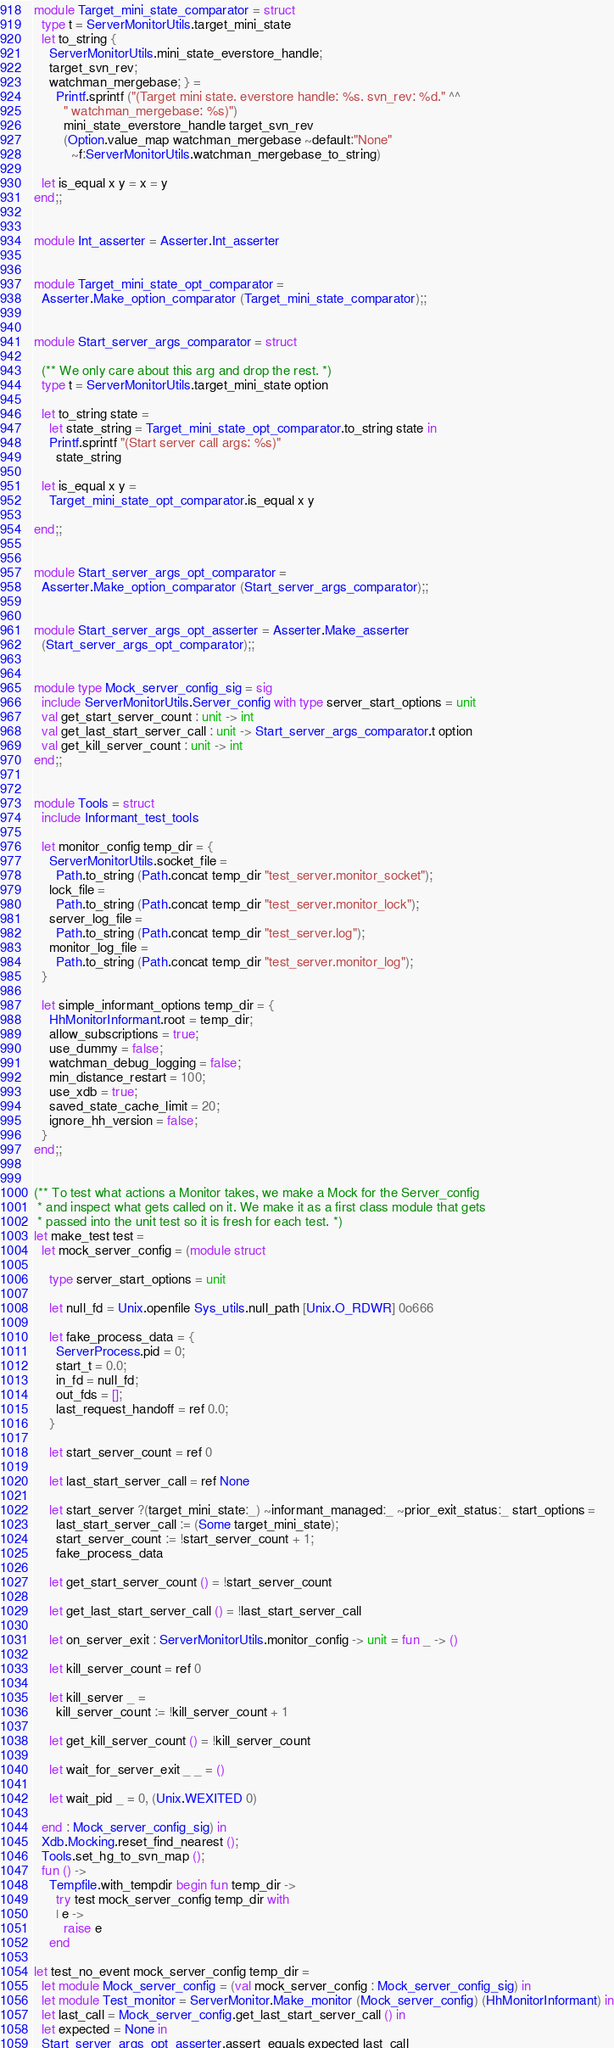Convert code to text. <code><loc_0><loc_0><loc_500><loc_500><_OCaml_>module Target_mini_state_comparator = struct
  type t = ServerMonitorUtils.target_mini_state
  let to_string {
    ServerMonitorUtils.mini_state_everstore_handle;
    target_svn_rev;
    watchman_mergebase; } =
      Printf.sprintf ("(Target mini state. everstore handle: %s. svn_rev: %d." ^^
        " watchman_mergebase: %s)")
        mini_state_everstore_handle target_svn_rev
        (Option.value_map watchman_mergebase ~default:"None"
          ~f:ServerMonitorUtils.watchman_mergebase_to_string)

  let is_equal x y = x = y
end;;


module Int_asserter = Asserter.Int_asserter


module Target_mini_state_opt_comparator =
  Asserter.Make_option_comparator (Target_mini_state_comparator);;


module Start_server_args_comparator = struct

  (** We only care about this arg and drop the rest. *)
  type t = ServerMonitorUtils.target_mini_state option

  let to_string state =
    let state_string = Target_mini_state_opt_comparator.to_string state in
    Printf.sprintf "(Start server call args: %s)"
      state_string

  let is_equal x y =
    Target_mini_state_opt_comparator.is_equal x y

end;;


module Start_server_args_opt_comparator =
  Asserter.Make_option_comparator (Start_server_args_comparator);;


module Start_server_args_opt_asserter = Asserter.Make_asserter
  (Start_server_args_opt_comparator);;


module type Mock_server_config_sig = sig
  include ServerMonitorUtils.Server_config with type server_start_options = unit
  val get_start_server_count : unit -> int
  val get_last_start_server_call : unit -> Start_server_args_comparator.t option
  val get_kill_server_count : unit -> int
end;;


module Tools = struct
  include Informant_test_tools

  let monitor_config temp_dir = {
    ServerMonitorUtils.socket_file =
      Path.to_string (Path.concat temp_dir "test_server.monitor_socket");
    lock_file =
      Path.to_string (Path.concat temp_dir "test_server.monitor_lock");
    server_log_file =
      Path.to_string (Path.concat temp_dir "test_server.log");
    monitor_log_file =
      Path.to_string (Path.concat temp_dir "test_server.monitor_log");
  }

  let simple_informant_options temp_dir = {
    HhMonitorInformant.root = temp_dir;
    allow_subscriptions = true;
    use_dummy = false;
    watchman_debug_logging = false;
    min_distance_restart = 100;
    use_xdb = true;
    saved_state_cache_limit = 20;
    ignore_hh_version = false;
  }
end;;


(** To test what actions a Monitor takes, we make a Mock for the Server_config
 * and inspect what gets called on it. We make it as a first class module that gets
 * passed into the unit test so it is fresh for each test. *)
let make_test test =
  let mock_server_config = (module struct

    type server_start_options = unit

    let null_fd = Unix.openfile Sys_utils.null_path [Unix.O_RDWR] 0o666

    let fake_process_data = {
      ServerProcess.pid = 0;
      start_t = 0.0;
      in_fd = null_fd;
      out_fds = [];
      last_request_handoff = ref 0.0;
    }

    let start_server_count = ref 0

    let last_start_server_call = ref None

    let start_server ?(target_mini_state:_) ~informant_managed:_ ~prior_exit_status:_ start_options =
      last_start_server_call := (Some target_mini_state);
      start_server_count := !start_server_count + 1;
      fake_process_data

    let get_start_server_count () = !start_server_count

    let get_last_start_server_call () = !last_start_server_call

    let on_server_exit : ServerMonitorUtils.monitor_config -> unit = fun _ -> ()

    let kill_server_count = ref 0

    let kill_server _ =
      kill_server_count := !kill_server_count + 1

    let get_kill_server_count () = !kill_server_count

    let wait_for_server_exit _ _ = ()

    let wait_pid _ = 0, (Unix.WEXITED 0)

  end : Mock_server_config_sig) in
  Xdb.Mocking.reset_find_nearest ();
  Tools.set_hg_to_svn_map ();
  fun () ->
    Tempfile.with_tempdir begin fun temp_dir ->
      try test mock_server_config temp_dir with
      | e ->
        raise e
    end

let test_no_event mock_server_config temp_dir =
  let module Mock_server_config = (val mock_server_config : Mock_server_config_sig) in
  let module Test_monitor = ServerMonitor.Make_monitor (Mock_server_config) (HhMonitorInformant) in
  let last_call = Mock_server_config.get_last_start_server_call () in
  let expected = None in
  Start_server_args_opt_asserter.assert_equals expected last_call</code> 